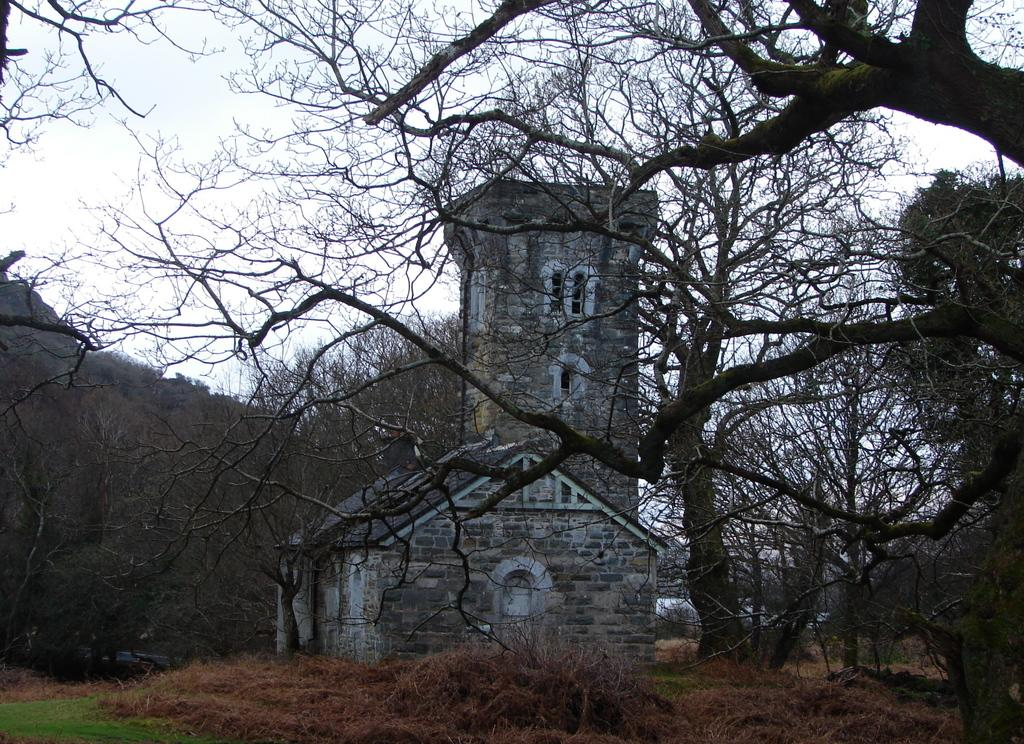What type of structure is present in the image? There is a house in the picture. What type of vegetation can be seen in the image? There is grass and trees in the picture. What is visible in the background of the image? The sky is visible in the background of the picture. How many geese are present in the picture? There are no geese present in the picture; it features a house, grass, trees, and the sky. What type of coat is hanging on the tree in the picture? There is no coat present in the picture; it only features a house, grass, trees, and the sky. 